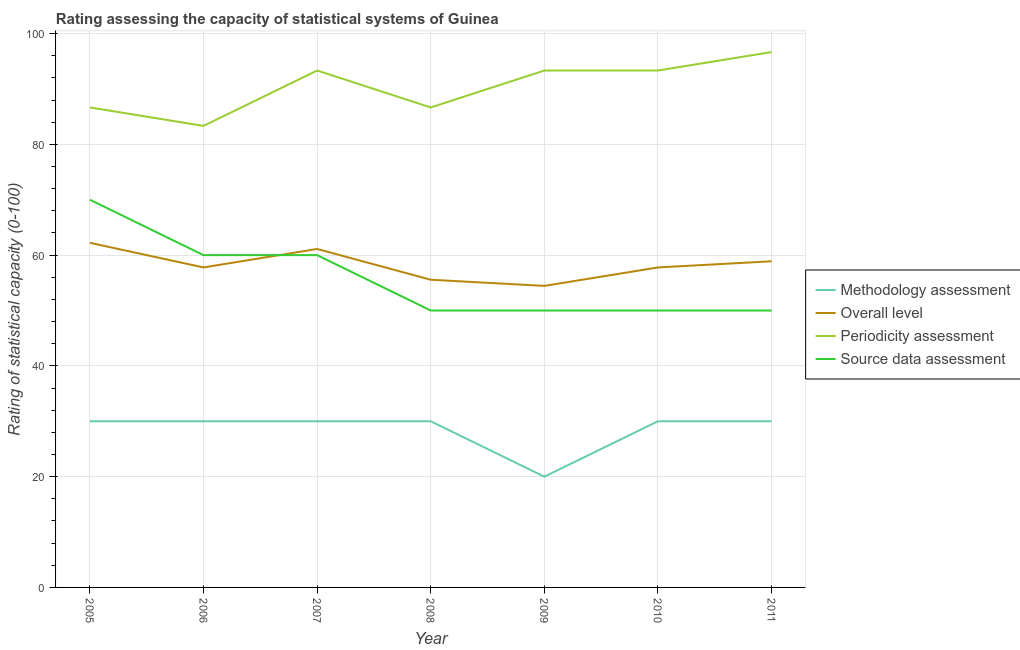How many different coloured lines are there?
Your answer should be compact. 4. What is the source data assessment rating in 2011?
Provide a short and direct response. 50. Across all years, what is the maximum periodicity assessment rating?
Give a very brief answer. 96.67. Across all years, what is the minimum methodology assessment rating?
Make the answer very short. 20. In which year was the source data assessment rating maximum?
Make the answer very short. 2005. In which year was the methodology assessment rating minimum?
Make the answer very short. 2009. What is the total methodology assessment rating in the graph?
Make the answer very short. 200. What is the difference between the methodology assessment rating in 2006 and that in 2010?
Provide a short and direct response. 0. What is the difference between the periodicity assessment rating in 2011 and the methodology assessment rating in 2005?
Your response must be concise. 66.67. What is the average overall level rating per year?
Your answer should be compact. 58.25. In the year 2011, what is the difference between the periodicity assessment rating and source data assessment rating?
Make the answer very short. 46.67. In how many years, is the methodology assessment rating greater than 12?
Make the answer very short. 7. What is the ratio of the overall level rating in 2005 to that in 2009?
Your response must be concise. 1.14. What is the difference between the highest and the second highest periodicity assessment rating?
Your response must be concise. 3.33. What is the difference between the highest and the lowest periodicity assessment rating?
Your answer should be compact. 13.33. In how many years, is the source data assessment rating greater than the average source data assessment rating taken over all years?
Keep it short and to the point. 3. Is the sum of the methodology assessment rating in 2007 and 2009 greater than the maximum overall level rating across all years?
Offer a terse response. No. Is it the case that in every year, the sum of the methodology assessment rating and overall level rating is greater than the periodicity assessment rating?
Provide a short and direct response. No. Does the graph contain any zero values?
Ensure brevity in your answer.  No. Does the graph contain grids?
Ensure brevity in your answer.  Yes. Where does the legend appear in the graph?
Keep it short and to the point. Center right. How are the legend labels stacked?
Offer a terse response. Vertical. What is the title of the graph?
Your answer should be very brief. Rating assessing the capacity of statistical systems of Guinea. Does "Grants and Revenue" appear as one of the legend labels in the graph?
Provide a short and direct response. No. What is the label or title of the X-axis?
Your answer should be very brief. Year. What is the label or title of the Y-axis?
Ensure brevity in your answer.  Rating of statistical capacity (0-100). What is the Rating of statistical capacity (0-100) in Overall level in 2005?
Your answer should be very brief. 62.22. What is the Rating of statistical capacity (0-100) in Periodicity assessment in 2005?
Offer a terse response. 86.67. What is the Rating of statistical capacity (0-100) of Methodology assessment in 2006?
Your answer should be compact. 30. What is the Rating of statistical capacity (0-100) in Overall level in 2006?
Make the answer very short. 57.78. What is the Rating of statistical capacity (0-100) of Periodicity assessment in 2006?
Your response must be concise. 83.33. What is the Rating of statistical capacity (0-100) in Overall level in 2007?
Provide a succinct answer. 61.11. What is the Rating of statistical capacity (0-100) of Periodicity assessment in 2007?
Provide a succinct answer. 93.33. What is the Rating of statistical capacity (0-100) in Source data assessment in 2007?
Give a very brief answer. 60. What is the Rating of statistical capacity (0-100) of Methodology assessment in 2008?
Your answer should be very brief. 30. What is the Rating of statistical capacity (0-100) in Overall level in 2008?
Ensure brevity in your answer.  55.56. What is the Rating of statistical capacity (0-100) in Periodicity assessment in 2008?
Your response must be concise. 86.67. What is the Rating of statistical capacity (0-100) in Source data assessment in 2008?
Your answer should be compact. 50. What is the Rating of statistical capacity (0-100) of Methodology assessment in 2009?
Make the answer very short. 20. What is the Rating of statistical capacity (0-100) of Overall level in 2009?
Your answer should be compact. 54.44. What is the Rating of statistical capacity (0-100) in Periodicity assessment in 2009?
Provide a short and direct response. 93.33. What is the Rating of statistical capacity (0-100) in Source data assessment in 2009?
Offer a very short reply. 50. What is the Rating of statistical capacity (0-100) of Overall level in 2010?
Your response must be concise. 57.78. What is the Rating of statistical capacity (0-100) of Periodicity assessment in 2010?
Offer a terse response. 93.33. What is the Rating of statistical capacity (0-100) of Source data assessment in 2010?
Your response must be concise. 50. What is the Rating of statistical capacity (0-100) of Overall level in 2011?
Offer a terse response. 58.89. What is the Rating of statistical capacity (0-100) of Periodicity assessment in 2011?
Keep it short and to the point. 96.67. What is the Rating of statistical capacity (0-100) in Source data assessment in 2011?
Make the answer very short. 50. Across all years, what is the maximum Rating of statistical capacity (0-100) of Overall level?
Your answer should be compact. 62.22. Across all years, what is the maximum Rating of statistical capacity (0-100) of Periodicity assessment?
Your answer should be very brief. 96.67. Across all years, what is the minimum Rating of statistical capacity (0-100) in Overall level?
Your answer should be very brief. 54.44. Across all years, what is the minimum Rating of statistical capacity (0-100) of Periodicity assessment?
Give a very brief answer. 83.33. What is the total Rating of statistical capacity (0-100) of Overall level in the graph?
Offer a terse response. 407.78. What is the total Rating of statistical capacity (0-100) of Periodicity assessment in the graph?
Provide a succinct answer. 633.33. What is the total Rating of statistical capacity (0-100) in Source data assessment in the graph?
Offer a terse response. 390. What is the difference between the Rating of statistical capacity (0-100) of Overall level in 2005 and that in 2006?
Your answer should be very brief. 4.44. What is the difference between the Rating of statistical capacity (0-100) in Methodology assessment in 2005 and that in 2007?
Your answer should be very brief. 0. What is the difference between the Rating of statistical capacity (0-100) in Overall level in 2005 and that in 2007?
Give a very brief answer. 1.11. What is the difference between the Rating of statistical capacity (0-100) of Periodicity assessment in 2005 and that in 2007?
Your answer should be very brief. -6.67. What is the difference between the Rating of statistical capacity (0-100) in Methodology assessment in 2005 and that in 2008?
Keep it short and to the point. 0. What is the difference between the Rating of statistical capacity (0-100) of Source data assessment in 2005 and that in 2008?
Make the answer very short. 20. What is the difference between the Rating of statistical capacity (0-100) of Methodology assessment in 2005 and that in 2009?
Offer a terse response. 10. What is the difference between the Rating of statistical capacity (0-100) in Overall level in 2005 and that in 2009?
Give a very brief answer. 7.78. What is the difference between the Rating of statistical capacity (0-100) of Periodicity assessment in 2005 and that in 2009?
Your response must be concise. -6.67. What is the difference between the Rating of statistical capacity (0-100) in Methodology assessment in 2005 and that in 2010?
Offer a very short reply. 0. What is the difference between the Rating of statistical capacity (0-100) in Overall level in 2005 and that in 2010?
Give a very brief answer. 4.44. What is the difference between the Rating of statistical capacity (0-100) in Periodicity assessment in 2005 and that in 2010?
Your answer should be very brief. -6.67. What is the difference between the Rating of statistical capacity (0-100) in Methodology assessment in 2005 and that in 2011?
Offer a very short reply. 0. What is the difference between the Rating of statistical capacity (0-100) in Overall level in 2005 and that in 2011?
Provide a succinct answer. 3.33. What is the difference between the Rating of statistical capacity (0-100) in Periodicity assessment in 2005 and that in 2011?
Offer a very short reply. -10. What is the difference between the Rating of statistical capacity (0-100) of Overall level in 2006 and that in 2007?
Give a very brief answer. -3.33. What is the difference between the Rating of statistical capacity (0-100) of Periodicity assessment in 2006 and that in 2007?
Keep it short and to the point. -10. What is the difference between the Rating of statistical capacity (0-100) in Source data assessment in 2006 and that in 2007?
Ensure brevity in your answer.  0. What is the difference between the Rating of statistical capacity (0-100) of Methodology assessment in 2006 and that in 2008?
Offer a terse response. 0. What is the difference between the Rating of statistical capacity (0-100) in Overall level in 2006 and that in 2008?
Your response must be concise. 2.22. What is the difference between the Rating of statistical capacity (0-100) in Methodology assessment in 2006 and that in 2009?
Make the answer very short. 10. What is the difference between the Rating of statistical capacity (0-100) in Periodicity assessment in 2006 and that in 2009?
Provide a succinct answer. -10. What is the difference between the Rating of statistical capacity (0-100) of Source data assessment in 2006 and that in 2009?
Offer a very short reply. 10. What is the difference between the Rating of statistical capacity (0-100) of Methodology assessment in 2006 and that in 2010?
Your response must be concise. 0. What is the difference between the Rating of statistical capacity (0-100) in Overall level in 2006 and that in 2010?
Offer a terse response. 0. What is the difference between the Rating of statistical capacity (0-100) in Source data assessment in 2006 and that in 2010?
Ensure brevity in your answer.  10. What is the difference between the Rating of statistical capacity (0-100) of Overall level in 2006 and that in 2011?
Offer a very short reply. -1.11. What is the difference between the Rating of statistical capacity (0-100) in Periodicity assessment in 2006 and that in 2011?
Your response must be concise. -13.33. What is the difference between the Rating of statistical capacity (0-100) in Overall level in 2007 and that in 2008?
Give a very brief answer. 5.56. What is the difference between the Rating of statistical capacity (0-100) of Source data assessment in 2007 and that in 2008?
Provide a succinct answer. 10. What is the difference between the Rating of statistical capacity (0-100) in Periodicity assessment in 2007 and that in 2009?
Ensure brevity in your answer.  0. What is the difference between the Rating of statistical capacity (0-100) in Overall level in 2007 and that in 2010?
Your answer should be very brief. 3.33. What is the difference between the Rating of statistical capacity (0-100) in Periodicity assessment in 2007 and that in 2010?
Offer a very short reply. 0. What is the difference between the Rating of statistical capacity (0-100) of Overall level in 2007 and that in 2011?
Your answer should be compact. 2.22. What is the difference between the Rating of statistical capacity (0-100) of Periodicity assessment in 2007 and that in 2011?
Keep it short and to the point. -3.33. What is the difference between the Rating of statistical capacity (0-100) in Methodology assessment in 2008 and that in 2009?
Offer a very short reply. 10. What is the difference between the Rating of statistical capacity (0-100) of Periodicity assessment in 2008 and that in 2009?
Make the answer very short. -6.67. What is the difference between the Rating of statistical capacity (0-100) of Source data assessment in 2008 and that in 2009?
Keep it short and to the point. 0. What is the difference between the Rating of statistical capacity (0-100) of Methodology assessment in 2008 and that in 2010?
Provide a succinct answer. 0. What is the difference between the Rating of statistical capacity (0-100) in Overall level in 2008 and that in 2010?
Keep it short and to the point. -2.22. What is the difference between the Rating of statistical capacity (0-100) in Periodicity assessment in 2008 and that in 2010?
Provide a succinct answer. -6.67. What is the difference between the Rating of statistical capacity (0-100) in Source data assessment in 2008 and that in 2010?
Make the answer very short. 0. What is the difference between the Rating of statistical capacity (0-100) in Methodology assessment in 2008 and that in 2011?
Make the answer very short. 0. What is the difference between the Rating of statistical capacity (0-100) of Overall level in 2008 and that in 2011?
Your answer should be compact. -3.33. What is the difference between the Rating of statistical capacity (0-100) in Periodicity assessment in 2008 and that in 2011?
Your response must be concise. -10. What is the difference between the Rating of statistical capacity (0-100) in Source data assessment in 2008 and that in 2011?
Your response must be concise. 0. What is the difference between the Rating of statistical capacity (0-100) of Methodology assessment in 2009 and that in 2011?
Make the answer very short. -10. What is the difference between the Rating of statistical capacity (0-100) of Overall level in 2009 and that in 2011?
Make the answer very short. -4.44. What is the difference between the Rating of statistical capacity (0-100) in Source data assessment in 2009 and that in 2011?
Offer a terse response. 0. What is the difference between the Rating of statistical capacity (0-100) of Methodology assessment in 2010 and that in 2011?
Your answer should be very brief. 0. What is the difference between the Rating of statistical capacity (0-100) in Overall level in 2010 and that in 2011?
Offer a terse response. -1.11. What is the difference between the Rating of statistical capacity (0-100) of Periodicity assessment in 2010 and that in 2011?
Provide a succinct answer. -3.33. What is the difference between the Rating of statistical capacity (0-100) of Source data assessment in 2010 and that in 2011?
Provide a succinct answer. 0. What is the difference between the Rating of statistical capacity (0-100) of Methodology assessment in 2005 and the Rating of statistical capacity (0-100) of Overall level in 2006?
Keep it short and to the point. -27.78. What is the difference between the Rating of statistical capacity (0-100) of Methodology assessment in 2005 and the Rating of statistical capacity (0-100) of Periodicity assessment in 2006?
Your response must be concise. -53.33. What is the difference between the Rating of statistical capacity (0-100) of Overall level in 2005 and the Rating of statistical capacity (0-100) of Periodicity assessment in 2006?
Ensure brevity in your answer.  -21.11. What is the difference between the Rating of statistical capacity (0-100) in Overall level in 2005 and the Rating of statistical capacity (0-100) in Source data assessment in 2006?
Your response must be concise. 2.22. What is the difference between the Rating of statistical capacity (0-100) of Periodicity assessment in 2005 and the Rating of statistical capacity (0-100) of Source data assessment in 2006?
Make the answer very short. 26.67. What is the difference between the Rating of statistical capacity (0-100) in Methodology assessment in 2005 and the Rating of statistical capacity (0-100) in Overall level in 2007?
Your answer should be compact. -31.11. What is the difference between the Rating of statistical capacity (0-100) of Methodology assessment in 2005 and the Rating of statistical capacity (0-100) of Periodicity assessment in 2007?
Give a very brief answer. -63.33. What is the difference between the Rating of statistical capacity (0-100) of Methodology assessment in 2005 and the Rating of statistical capacity (0-100) of Source data assessment in 2007?
Your answer should be compact. -30. What is the difference between the Rating of statistical capacity (0-100) in Overall level in 2005 and the Rating of statistical capacity (0-100) in Periodicity assessment in 2007?
Your answer should be very brief. -31.11. What is the difference between the Rating of statistical capacity (0-100) in Overall level in 2005 and the Rating of statistical capacity (0-100) in Source data assessment in 2007?
Your response must be concise. 2.22. What is the difference between the Rating of statistical capacity (0-100) in Periodicity assessment in 2005 and the Rating of statistical capacity (0-100) in Source data assessment in 2007?
Offer a very short reply. 26.67. What is the difference between the Rating of statistical capacity (0-100) in Methodology assessment in 2005 and the Rating of statistical capacity (0-100) in Overall level in 2008?
Ensure brevity in your answer.  -25.56. What is the difference between the Rating of statistical capacity (0-100) in Methodology assessment in 2005 and the Rating of statistical capacity (0-100) in Periodicity assessment in 2008?
Provide a short and direct response. -56.67. What is the difference between the Rating of statistical capacity (0-100) of Overall level in 2005 and the Rating of statistical capacity (0-100) of Periodicity assessment in 2008?
Give a very brief answer. -24.44. What is the difference between the Rating of statistical capacity (0-100) of Overall level in 2005 and the Rating of statistical capacity (0-100) of Source data assessment in 2008?
Provide a succinct answer. 12.22. What is the difference between the Rating of statistical capacity (0-100) in Periodicity assessment in 2005 and the Rating of statistical capacity (0-100) in Source data assessment in 2008?
Offer a very short reply. 36.67. What is the difference between the Rating of statistical capacity (0-100) of Methodology assessment in 2005 and the Rating of statistical capacity (0-100) of Overall level in 2009?
Ensure brevity in your answer.  -24.44. What is the difference between the Rating of statistical capacity (0-100) in Methodology assessment in 2005 and the Rating of statistical capacity (0-100) in Periodicity assessment in 2009?
Provide a succinct answer. -63.33. What is the difference between the Rating of statistical capacity (0-100) of Methodology assessment in 2005 and the Rating of statistical capacity (0-100) of Source data assessment in 2009?
Ensure brevity in your answer.  -20. What is the difference between the Rating of statistical capacity (0-100) in Overall level in 2005 and the Rating of statistical capacity (0-100) in Periodicity assessment in 2009?
Keep it short and to the point. -31.11. What is the difference between the Rating of statistical capacity (0-100) in Overall level in 2005 and the Rating of statistical capacity (0-100) in Source data assessment in 2009?
Provide a short and direct response. 12.22. What is the difference between the Rating of statistical capacity (0-100) in Periodicity assessment in 2005 and the Rating of statistical capacity (0-100) in Source data assessment in 2009?
Provide a succinct answer. 36.67. What is the difference between the Rating of statistical capacity (0-100) in Methodology assessment in 2005 and the Rating of statistical capacity (0-100) in Overall level in 2010?
Give a very brief answer. -27.78. What is the difference between the Rating of statistical capacity (0-100) in Methodology assessment in 2005 and the Rating of statistical capacity (0-100) in Periodicity assessment in 2010?
Your answer should be very brief. -63.33. What is the difference between the Rating of statistical capacity (0-100) of Overall level in 2005 and the Rating of statistical capacity (0-100) of Periodicity assessment in 2010?
Provide a short and direct response. -31.11. What is the difference between the Rating of statistical capacity (0-100) in Overall level in 2005 and the Rating of statistical capacity (0-100) in Source data assessment in 2010?
Your answer should be compact. 12.22. What is the difference between the Rating of statistical capacity (0-100) of Periodicity assessment in 2005 and the Rating of statistical capacity (0-100) of Source data assessment in 2010?
Offer a very short reply. 36.67. What is the difference between the Rating of statistical capacity (0-100) in Methodology assessment in 2005 and the Rating of statistical capacity (0-100) in Overall level in 2011?
Keep it short and to the point. -28.89. What is the difference between the Rating of statistical capacity (0-100) of Methodology assessment in 2005 and the Rating of statistical capacity (0-100) of Periodicity assessment in 2011?
Offer a terse response. -66.67. What is the difference between the Rating of statistical capacity (0-100) of Methodology assessment in 2005 and the Rating of statistical capacity (0-100) of Source data assessment in 2011?
Provide a short and direct response. -20. What is the difference between the Rating of statistical capacity (0-100) in Overall level in 2005 and the Rating of statistical capacity (0-100) in Periodicity assessment in 2011?
Offer a very short reply. -34.44. What is the difference between the Rating of statistical capacity (0-100) of Overall level in 2005 and the Rating of statistical capacity (0-100) of Source data assessment in 2011?
Keep it short and to the point. 12.22. What is the difference between the Rating of statistical capacity (0-100) of Periodicity assessment in 2005 and the Rating of statistical capacity (0-100) of Source data assessment in 2011?
Ensure brevity in your answer.  36.67. What is the difference between the Rating of statistical capacity (0-100) of Methodology assessment in 2006 and the Rating of statistical capacity (0-100) of Overall level in 2007?
Provide a short and direct response. -31.11. What is the difference between the Rating of statistical capacity (0-100) in Methodology assessment in 2006 and the Rating of statistical capacity (0-100) in Periodicity assessment in 2007?
Ensure brevity in your answer.  -63.33. What is the difference between the Rating of statistical capacity (0-100) of Overall level in 2006 and the Rating of statistical capacity (0-100) of Periodicity assessment in 2007?
Your response must be concise. -35.56. What is the difference between the Rating of statistical capacity (0-100) in Overall level in 2006 and the Rating of statistical capacity (0-100) in Source data assessment in 2007?
Make the answer very short. -2.22. What is the difference between the Rating of statistical capacity (0-100) of Periodicity assessment in 2006 and the Rating of statistical capacity (0-100) of Source data assessment in 2007?
Your answer should be very brief. 23.33. What is the difference between the Rating of statistical capacity (0-100) in Methodology assessment in 2006 and the Rating of statistical capacity (0-100) in Overall level in 2008?
Your answer should be very brief. -25.56. What is the difference between the Rating of statistical capacity (0-100) in Methodology assessment in 2006 and the Rating of statistical capacity (0-100) in Periodicity assessment in 2008?
Provide a short and direct response. -56.67. What is the difference between the Rating of statistical capacity (0-100) in Methodology assessment in 2006 and the Rating of statistical capacity (0-100) in Source data assessment in 2008?
Offer a terse response. -20. What is the difference between the Rating of statistical capacity (0-100) in Overall level in 2006 and the Rating of statistical capacity (0-100) in Periodicity assessment in 2008?
Your answer should be very brief. -28.89. What is the difference between the Rating of statistical capacity (0-100) in Overall level in 2006 and the Rating of statistical capacity (0-100) in Source data assessment in 2008?
Ensure brevity in your answer.  7.78. What is the difference between the Rating of statistical capacity (0-100) in Periodicity assessment in 2006 and the Rating of statistical capacity (0-100) in Source data assessment in 2008?
Offer a terse response. 33.33. What is the difference between the Rating of statistical capacity (0-100) in Methodology assessment in 2006 and the Rating of statistical capacity (0-100) in Overall level in 2009?
Keep it short and to the point. -24.44. What is the difference between the Rating of statistical capacity (0-100) in Methodology assessment in 2006 and the Rating of statistical capacity (0-100) in Periodicity assessment in 2009?
Provide a short and direct response. -63.33. What is the difference between the Rating of statistical capacity (0-100) in Overall level in 2006 and the Rating of statistical capacity (0-100) in Periodicity assessment in 2009?
Offer a very short reply. -35.56. What is the difference between the Rating of statistical capacity (0-100) of Overall level in 2006 and the Rating of statistical capacity (0-100) of Source data assessment in 2009?
Keep it short and to the point. 7.78. What is the difference between the Rating of statistical capacity (0-100) of Periodicity assessment in 2006 and the Rating of statistical capacity (0-100) of Source data assessment in 2009?
Your answer should be very brief. 33.33. What is the difference between the Rating of statistical capacity (0-100) of Methodology assessment in 2006 and the Rating of statistical capacity (0-100) of Overall level in 2010?
Ensure brevity in your answer.  -27.78. What is the difference between the Rating of statistical capacity (0-100) of Methodology assessment in 2006 and the Rating of statistical capacity (0-100) of Periodicity assessment in 2010?
Ensure brevity in your answer.  -63.33. What is the difference between the Rating of statistical capacity (0-100) in Overall level in 2006 and the Rating of statistical capacity (0-100) in Periodicity assessment in 2010?
Keep it short and to the point. -35.56. What is the difference between the Rating of statistical capacity (0-100) of Overall level in 2006 and the Rating of statistical capacity (0-100) of Source data assessment in 2010?
Keep it short and to the point. 7.78. What is the difference between the Rating of statistical capacity (0-100) in Periodicity assessment in 2006 and the Rating of statistical capacity (0-100) in Source data assessment in 2010?
Offer a terse response. 33.33. What is the difference between the Rating of statistical capacity (0-100) of Methodology assessment in 2006 and the Rating of statistical capacity (0-100) of Overall level in 2011?
Ensure brevity in your answer.  -28.89. What is the difference between the Rating of statistical capacity (0-100) in Methodology assessment in 2006 and the Rating of statistical capacity (0-100) in Periodicity assessment in 2011?
Your answer should be very brief. -66.67. What is the difference between the Rating of statistical capacity (0-100) in Overall level in 2006 and the Rating of statistical capacity (0-100) in Periodicity assessment in 2011?
Your response must be concise. -38.89. What is the difference between the Rating of statistical capacity (0-100) in Overall level in 2006 and the Rating of statistical capacity (0-100) in Source data assessment in 2011?
Provide a short and direct response. 7.78. What is the difference between the Rating of statistical capacity (0-100) in Periodicity assessment in 2006 and the Rating of statistical capacity (0-100) in Source data assessment in 2011?
Ensure brevity in your answer.  33.33. What is the difference between the Rating of statistical capacity (0-100) of Methodology assessment in 2007 and the Rating of statistical capacity (0-100) of Overall level in 2008?
Your answer should be very brief. -25.56. What is the difference between the Rating of statistical capacity (0-100) of Methodology assessment in 2007 and the Rating of statistical capacity (0-100) of Periodicity assessment in 2008?
Your response must be concise. -56.67. What is the difference between the Rating of statistical capacity (0-100) of Overall level in 2007 and the Rating of statistical capacity (0-100) of Periodicity assessment in 2008?
Your answer should be very brief. -25.56. What is the difference between the Rating of statistical capacity (0-100) of Overall level in 2007 and the Rating of statistical capacity (0-100) of Source data assessment in 2008?
Your answer should be very brief. 11.11. What is the difference between the Rating of statistical capacity (0-100) of Periodicity assessment in 2007 and the Rating of statistical capacity (0-100) of Source data assessment in 2008?
Offer a very short reply. 43.33. What is the difference between the Rating of statistical capacity (0-100) in Methodology assessment in 2007 and the Rating of statistical capacity (0-100) in Overall level in 2009?
Your answer should be very brief. -24.44. What is the difference between the Rating of statistical capacity (0-100) in Methodology assessment in 2007 and the Rating of statistical capacity (0-100) in Periodicity assessment in 2009?
Ensure brevity in your answer.  -63.33. What is the difference between the Rating of statistical capacity (0-100) in Overall level in 2007 and the Rating of statistical capacity (0-100) in Periodicity assessment in 2009?
Provide a short and direct response. -32.22. What is the difference between the Rating of statistical capacity (0-100) of Overall level in 2007 and the Rating of statistical capacity (0-100) of Source data assessment in 2009?
Give a very brief answer. 11.11. What is the difference between the Rating of statistical capacity (0-100) in Periodicity assessment in 2007 and the Rating of statistical capacity (0-100) in Source data assessment in 2009?
Ensure brevity in your answer.  43.33. What is the difference between the Rating of statistical capacity (0-100) in Methodology assessment in 2007 and the Rating of statistical capacity (0-100) in Overall level in 2010?
Offer a very short reply. -27.78. What is the difference between the Rating of statistical capacity (0-100) of Methodology assessment in 2007 and the Rating of statistical capacity (0-100) of Periodicity assessment in 2010?
Offer a very short reply. -63.33. What is the difference between the Rating of statistical capacity (0-100) in Overall level in 2007 and the Rating of statistical capacity (0-100) in Periodicity assessment in 2010?
Make the answer very short. -32.22. What is the difference between the Rating of statistical capacity (0-100) of Overall level in 2007 and the Rating of statistical capacity (0-100) of Source data assessment in 2010?
Offer a very short reply. 11.11. What is the difference between the Rating of statistical capacity (0-100) of Periodicity assessment in 2007 and the Rating of statistical capacity (0-100) of Source data assessment in 2010?
Keep it short and to the point. 43.33. What is the difference between the Rating of statistical capacity (0-100) in Methodology assessment in 2007 and the Rating of statistical capacity (0-100) in Overall level in 2011?
Your answer should be very brief. -28.89. What is the difference between the Rating of statistical capacity (0-100) in Methodology assessment in 2007 and the Rating of statistical capacity (0-100) in Periodicity assessment in 2011?
Your response must be concise. -66.67. What is the difference between the Rating of statistical capacity (0-100) of Overall level in 2007 and the Rating of statistical capacity (0-100) of Periodicity assessment in 2011?
Your answer should be very brief. -35.56. What is the difference between the Rating of statistical capacity (0-100) in Overall level in 2007 and the Rating of statistical capacity (0-100) in Source data assessment in 2011?
Offer a terse response. 11.11. What is the difference between the Rating of statistical capacity (0-100) in Periodicity assessment in 2007 and the Rating of statistical capacity (0-100) in Source data assessment in 2011?
Offer a terse response. 43.33. What is the difference between the Rating of statistical capacity (0-100) in Methodology assessment in 2008 and the Rating of statistical capacity (0-100) in Overall level in 2009?
Your answer should be very brief. -24.44. What is the difference between the Rating of statistical capacity (0-100) of Methodology assessment in 2008 and the Rating of statistical capacity (0-100) of Periodicity assessment in 2009?
Ensure brevity in your answer.  -63.33. What is the difference between the Rating of statistical capacity (0-100) of Methodology assessment in 2008 and the Rating of statistical capacity (0-100) of Source data assessment in 2009?
Offer a terse response. -20. What is the difference between the Rating of statistical capacity (0-100) in Overall level in 2008 and the Rating of statistical capacity (0-100) in Periodicity assessment in 2009?
Your answer should be compact. -37.78. What is the difference between the Rating of statistical capacity (0-100) of Overall level in 2008 and the Rating of statistical capacity (0-100) of Source data assessment in 2009?
Your answer should be compact. 5.56. What is the difference between the Rating of statistical capacity (0-100) in Periodicity assessment in 2008 and the Rating of statistical capacity (0-100) in Source data assessment in 2009?
Keep it short and to the point. 36.67. What is the difference between the Rating of statistical capacity (0-100) of Methodology assessment in 2008 and the Rating of statistical capacity (0-100) of Overall level in 2010?
Ensure brevity in your answer.  -27.78. What is the difference between the Rating of statistical capacity (0-100) in Methodology assessment in 2008 and the Rating of statistical capacity (0-100) in Periodicity assessment in 2010?
Provide a short and direct response. -63.33. What is the difference between the Rating of statistical capacity (0-100) in Methodology assessment in 2008 and the Rating of statistical capacity (0-100) in Source data assessment in 2010?
Make the answer very short. -20. What is the difference between the Rating of statistical capacity (0-100) of Overall level in 2008 and the Rating of statistical capacity (0-100) of Periodicity assessment in 2010?
Provide a succinct answer. -37.78. What is the difference between the Rating of statistical capacity (0-100) in Overall level in 2008 and the Rating of statistical capacity (0-100) in Source data assessment in 2010?
Offer a terse response. 5.56. What is the difference between the Rating of statistical capacity (0-100) in Periodicity assessment in 2008 and the Rating of statistical capacity (0-100) in Source data assessment in 2010?
Provide a succinct answer. 36.67. What is the difference between the Rating of statistical capacity (0-100) of Methodology assessment in 2008 and the Rating of statistical capacity (0-100) of Overall level in 2011?
Keep it short and to the point. -28.89. What is the difference between the Rating of statistical capacity (0-100) in Methodology assessment in 2008 and the Rating of statistical capacity (0-100) in Periodicity assessment in 2011?
Your response must be concise. -66.67. What is the difference between the Rating of statistical capacity (0-100) of Methodology assessment in 2008 and the Rating of statistical capacity (0-100) of Source data assessment in 2011?
Give a very brief answer. -20. What is the difference between the Rating of statistical capacity (0-100) in Overall level in 2008 and the Rating of statistical capacity (0-100) in Periodicity assessment in 2011?
Your response must be concise. -41.11. What is the difference between the Rating of statistical capacity (0-100) in Overall level in 2008 and the Rating of statistical capacity (0-100) in Source data assessment in 2011?
Offer a terse response. 5.56. What is the difference between the Rating of statistical capacity (0-100) of Periodicity assessment in 2008 and the Rating of statistical capacity (0-100) of Source data assessment in 2011?
Ensure brevity in your answer.  36.67. What is the difference between the Rating of statistical capacity (0-100) of Methodology assessment in 2009 and the Rating of statistical capacity (0-100) of Overall level in 2010?
Your answer should be very brief. -37.78. What is the difference between the Rating of statistical capacity (0-100) in Methodology assessment in 2009 and the Rating of statistical capacity (0-100) in Periodicity assessment in 2010?
Keep it short and to the point. -73.33. What is the difference between the Rating of statistical capacity (0-100) of Overall level in 2009 and the Rating of statistical capacity (0-100) of Periodicity assessment in 2010?
Your answer should be very brief. -38.89. What is the difference between the Rating of statistical capacity (0-100) in Overall level in 2009 and the Rating of statistical capacity (0-100) in Source data assessment in 2010?
Your response must be concise. 4.44. What is the difference between the Rating of statistical capacity (0-100) of Periodicity assessment in 2009 and the Rating of statistical capacity (0-100) of Source data assessment in 2010?
Your answer should be compact. 43.33. What is the difference between the Rating of statistical capacity (0-100) in Methodology assessment in 2009 and the Rating of statistical capacity (0-100) in Overall level in 2011?
Offer a very short reply. -38.89. What is the difference between the Rating of statistical capacity (0-100) in Methodology assessment in 2009 and the Rating of statistical capacity (0-100) in Periodicity assessment in 2011?
Provide a succinct answer. -76.67. What is the difference between the Rating of statistical capacity (0-100) of Methodology assessment in 2009 and the Rating of statistical capacity (0-100) of Source data assessment in 2011?
Provide a succinct answer. -30. What is the difference between the Rating of statistical capacity (0-100) in Overall level in 2009 and the Rating of statistical capacity (0-100) in Periodicity assessment in 2011?
Make the answer very short. -42.22. What is the difference between the Rating of statistical capacity (0-100) in Overall level in 2009 and the Rating of statistical capacity (0-100) in Source data assessment in 2011?
Offer a very short reply. 4.44. What is the difference between the Rating of statistical capacity (0-100) of Periodicity assessment in 2009 and the Rating of statistical capacity (0-100) of Source data assessment in 2011?
Your answer should be compact. 43.33. What is the difference between the Rating of statistical capacity (0-100) of Methodology assessment in 2010 and the Rating of statistical capacity (0-100) of Overall level in 2011?
Provide a short and direct response. -28.89. What is the difference between the Rating of statistical capacity (0-100) in Methodology assessment in 2010 and the Rating of statistical capacity (0-100) in Periodicity assessment in 2011?
Provide a succinct answer. -66.67. What is the difference between the Rating of statistical capacity (0-100) in Methodology assessment in 2010 and the Rating of statistical capacity (0-100) in Source data assessment in 2011?
Offer a terse response. -20. What is the difference between the Rating of statistical capacity (0-100) of Overall level in 2010 and the Rating of statistical capacity (0-100) of Periodicity assessment in 2011?
Make the answer very short. -38.89. What is the difference between the Rating of statistical capacity (0-100) of Overall level in 2010 and the Rating of statistical capacity (0-100) of Source data assessment in 2011?
Keep it short and to the point. 7.78. What is the difference between the Rating of statistical capacity (0-100) of Periodicity assessment in 2010 and the Rating of statistical capacity (0-100) of Source data assessment in 2011?
Provide a succinct answer. 43.33. What is the average Rating of statistical capacity (0-100) of Methodology assessment per year?
Provide a short and direct response. 28.57. What is the average Rating of statistical capacity (0-100) of Overall level per year?
Provide a succinct answer. 58.25. What is the average Rating of statistical capacity (0-100) of Periodicity assessment per year?
Your answer should be very brief. 90.48. What is the average Rating of statistical capacity (0-100) in Source data assessment per year?
Keep it short and to the point. 55.71. In the year 2005, what is the difference between the Rating of statistical capacity (0-100) in Methodology assessment and Rating of statistical capacity (0-100) in Overall level?
Your response must be concise. -32.22. In the year 2005, what is the difference between the Rating of statistical capacity (0-100) in Methodology assessment and Rating of statistical capacity (0-100) in Periodicity assessment?
Your response must be concise. -56.67. In the year 2005, what is the difference between the Rating of statistical capacity (0-100) in Overall level and Rating of statistical capacity (0-100) in Periodicity assessment?
Your answer should be compact. -24.44. In the year 2005, what is the difference between the Rating of statistical capacity (0-100) in Overall level and Rating of statistical capacity (0-100) in Source data assessment?
Give a very brief answer. -7.78. In the year 2005, what is the difference between the Rating of statistical capacity (0-100) of Periodicity assessment and Rating of statistical capacity (0-100) of Source data assessment?
Offer a terse response. 16.67. In the year 2006, what is the difference between the Rating of statistical capacity (0-100) in Methodology assessment and Rating of statistical capacity (0-100) in Overall level?
Your answer should be very brief. -27.78. In the year 2006, what is the difference between the Rating of statistical capacity (0-100) of Methodology assessment and Rating of statistical capacity (0-100) of Periodicity assessment?
Offer a terse response. -53.33. In the year 2006, what is the difference between the Rating of statistical capacity (0-100) in Methodology assessment and Rating of statistical capacity (0-100) in Source data assessment?
Ensure brevity in your answer.  -30. In the year 2006, what is the difference between the Rating of statistical capacity (0-100) of Overall level and Rating of statistical capacity (0-100) of Periodicity assessment?
Your response must be concise. -25.56. In the year 2006, what is the difference between the Rating of statistical capacity (0-100) of Overall level and Rating of statistical capacity (0-100) of Source data assessment?
Your answer should be very brief. -2.22. In the year 2006, what is the difference between the Rating of statistical capacity (0-100) in Periodicity assessment and Rating of statistical capacity (0-100) in Source data assessment?
Provide a succinct answer. 23.33. In the year 2007, what is the difference between the Rating of statistical capacity (0-100) in Methodology assessment and Rating of statistical capacity (0-100) in Overall level?
Provide a succinct answer. -31.11. In the year 2007, what is the difference between the Rating of statistical capacity (0-100) in Methodology assessment and Rating of statistical capacity (0-100) in Periodicity assessment?
Your response must be concise. -63.33. In the year 2007, what is the difference between the Rating of statistical capacity (0-100) in Overall level and Rating of statistical capacity (0-100) in Periodicity assessment?
Make the answer very short. -32.22. In the year 2007, what is the difference between the Rating of statistical capacity (0-100) in Periodicity assessment and Rating of statistical capacity (0-100) in Source data assessment?
Make the answer very short. 33.33. In the year 2008, what is the difference between the Rating of statistical capacity (0-100) of Methodology assessment and Rating of statistical capacity (0-100) of Overall level?
Your response must be concise. -25.56. In the year 2008, what is the difference between the Rating of statistical capacity (0-100) of Methodology assessment and Rating of statistical capacity (0-100) of Periodicity assessment?
Your response must be concise. -56.67. In the year 2008, what is the difference between the Rating of statistical capacity (0-100) of Methodology assessment and Rating of statistical capacity (0-100) of Source data assessment?
Provide a succinct answer. -20. In the year 2008, what is the difference between the Rating of statistical capacity (0-100) of Overall level and Rating of statistical capacity (0-100) of Periodicity assessment?
Provide a succinct answer. -31.11. In the year 2008, what is the difference between the Rating of statistical capacity (0-100) in Overall level and Rating of statistical capacity (0-100) in Source data assessment?
Ensure brevity in your answer.  5.56. In the year 2008, what is the difference between the Rating of statistical capacity (0-100) in Periodicity assessment and Rating of statistical capacity (0-100) in Source data assessment?
Provide a succinct answer. 36.67. In the year 2009, what is the difference between the Rating of statistical capacity (0-100) of Methodology assessment and Rating of statistical capacity (0-100) of Overall level?
Offer a very short reply. -34.44. In the year 2009, what is the difference between the Rating of statistical capacity (0-100) in Methodology assessment and Rating of statistical capacity (0-100) in Periodicity assessment?
Offer a terse response. -73.33. In the year 2009, what is the difference between the Rating of statistical capacity (0-100) in Overall level and Rating of statistical capacity (0-100) in Periodicity assessment?
Give a very brief answer. -38.89. In the year 2009, what is the difference between the Rating of statistical capacity (0-100) in Overall level and Rating of statistical capacity (0-100) in Source data assessment?
Offer a very short reply. 4.44. In the year 2009, what is the difference between the Rating of statistical capacity (0-100) in Periodicity assessment and Rating of statistical capacity (0-100) in Source data assessment?
Make the answer very short. 43.33. In the year 2010, what is the difference between the Rating of statistical capacity (0-100) in Methodology assessment and Rating of statistical capacity (0-100) in Overall level?
Provide a succinct answer. -27.78. In the year 2010, what is the difference between the Rating of statistical capacity (0-100) of Methodology assessment and Rating of statistical capacity (0-100) of Periodicity assessment?
Give a very brief answer. -63.33. In the year 2010, what is the difference between the Rating of statistical capacity (0-100) in Methodology assessment and Rating of statistical capacity (0-100) in Source data assessment?
Provide a short and direct response. -20. In the year 2010, what is the difference between the Rating of statistical capacity (0-100) in Overall level and Rating of statistical capacity (0-100) in Periodicity assessment?
Provide a succinct answer. -35.56. In the year 2010, what is the difference between the Rating of statistical capacity (0-100) of Overall level and Rating of statistical capacity (0-100) of Source data assessment?
Make the answer very short. 7.78. In the year 2010, what is the difference between the Rating of statistical capacity (0-100) in Periodicity assessment and Rating of statistical capacity (0-100) in Source data assessment?
Give a very brief answer. 43.33. In the year 2011, what is the difference between the Rating of statistical capacity (0-100) of Methodology assessment and Rating of statistical capacity (0-100) of Overall level?
Your response must be concise. -28.89. In the year 2011, what is the difference between the Rating of statistical capacity (0-100) of Methodology assessment and Rating of statistical capacity (0-100) of Periodicity assessment?
Keep it short and to the point. -66.67. In the year 2011, what is the difference between the Rating of statistical capacity (0-100) of Overall level and Rating of statistical capacity (0-100) of Periodicity assessment?
Your response must be concise. -37.78. In the year 2011, what is the difference between the Rating of statistical capacity (0-100) in Overall level and Rating of statistical capacity (0-100) in Source data assessment?
Offer a very short reply. 8.89. In the year 2011, what is the difference between the Rating of statistical capacity (0-100) in Periodicity assessment and Rating of statistical capacity (0-100) in Source data assessment?
Your response must be concise. 46.67. What is the ratio of the Rating of statistical capacity (0-100) of Overall level in 2005 to that in 2006?
Offer a terse response. 1.08. What is the ratio of the Rating of statistical capacity (0-100) in Periodicity assessment in 2005 to that in 2006?
Make the answer very short. 1.04. What is the ratio of the Rating of statistical capacity (0-100) of Overall level in 2005 to that in 2007?
Provide a short and direct response. 1.02. What is the ratio of the Rating of statistical capacity (0-100) of Methodology assessment in 2005 to that in 2008?
Your answer should be very brief. 1. What is the ratio of the Rating of statistical capacity (0-100) of Overall level in 2005 to that in 2008?
Your response must be concise. 1.12. What is the ratio of the Rating of statistical capacity (0-100) in Periodicity assessment in 2005 to that in 2008?
Provide a succinct answer. 1. What is the ratio of the Rating of statistical capacity (0-100) of Methodology assessment in 2005 to that in 2010?
Give a very brief answer. 1. What is the ratio of the Rating of statistical capacity (0-100) in Overall level in 2005 to that in 2010?
Your answer should be very brief. 1.08. What is the ratio of the Rating of statistical capacity (0-100) in Periodicity assessment in 2005 to that in 2010?
Your answer should be compact. 0.93. What is the ratio of the Rating of statistical capacity (0-100) of Source data assessment in 2005 to that in 2010?
Your answer should be compact. 1.4. What is the ratio of the Rating of statistical capacity (0-100) in Overall level in 2005 to that in 2011?
Keep it short and to the point. 1.06. What is the ratio of the Rating of statistical capacity (0-100) in Periodicity assessment in 2005 to that in 2011?
Your answer should be compact. 0.9. What is the ratio of the Rating of statistical capacity (0-100) of Source data assessment in 2005 to that in 2011?
Provide a short and direct response. 1.4. What is the ratio of the Rating of statistical capacity (0-100) in Methodology assessment in 2006 to that in 2007?
Your response must be concise. 1. What is the ratio of the Rating of statistical capacity (0-100) in Overall level in 2006 to that in 2007?
Your response must be concise. 0.95. What is the ratio of the Rating of statistical capacity (0-100) in Periodicity assessment in 2006 to that in 2007?
Your response must be concise. 0.89. What is the ratio of the Rating of statistical capacity (0-100) of Overall level in 2006 to that in 2008?
Keep it short and to the point. 1.04. What is the ratio of the Rating of statistical capacity (0-100) of Periodicity assessment in 2006 to that in 2008?
Keep it short and to the point. 0.96. What is the ratio of the Rating of statistical capacity (0-100) in Source data assessment in 2006 to that in 2008?
Provide a short and direct response. 1.2. What is the ratio of the Rating of statistical capacity (0-100) in Overall level in 2006 to that in 2009?
Ensure brevity in your answer.  1.06. What is the ratio of the Rating of statistical capacity (0-100) in Periodicity assessment in 2006 to that in 2009?
Your answer should be compact. 0.89. What is the ratio of the Rating of statistical capacity (0-100) of Overall level in 2006 to that in 2010?
Make the answer very short. 1. What is the ratio of the Rating of statistical capacity (0-100) in Periodicity assessment in 2006 to that in 2010?
Provide a succinct answer. 0.89. What is the ratio of the Rating of statistical capacity (0-100) of Source data assessment in 2006 to that in 2010?
Give a very brief answer. 1.2. What is the ratio of the Rating of statistical capacity (0-100) in Overall level in 2006 to that in 2011?
Offer a very short reply. 0.98. What is the ratio of the Rating of statistical capacity (0-100) in Periodicity assessment in 2006 to that in 2011?
Ensure brevity in your answer.  0.86. What is the ratio of the Rating of statistical capacity (0-100) in Overall level in 2007 to that in 2009?
Provide a short and direct response. 1.12. What is the ratio of the Rating of statistical capacity (0-100) of Periodicity assessment in 2007 to that in 2009?
Your answer should be very brief. 1. What is the ratio of the Rating of statistical capacity (0-100) of Methodology assessment in 2007 to that in 2010?
Provide a short and direct response. 1. What is the ratio of the Rating of statistical capacity (0-100) in Overall level in 2007 to that in 2010?
Ensure brevity in your answer.  1.06. What is the ratio of the Rating of statistical capacity (0-100) of Periodicity assessment in 2007 to that in 2010?
Ensure brevity in your answer.  1. What is the ratio of the Rating of statistical capacity (0-100) in Methodology assessment in 2007 to that in 2011?
Keep it short and to the point. 1. What is the ratio of the Rating of statistical capacity (0-100) of Overall level in 2007 to that in 2011?
Offer a very short reply. 1.04. What is the ratio of the Rating of statistical capacity (0-100) in Periodicity assessment in 2007 to that in 2011?
Offer a very short reply. 0.97. What is the ratio of the Rating of statistical capacity (0-100) in Methodology assessment in 2008 to that in 2009?
Your response must be concise. 1.5. What is the ratio of the Rating of statistical capacity (0-100) of Overall level in 2008 to that in 2009?
Offer a very short reply. 1.02. What is the ratio of the Rating of statistical capacity (0-100) in Periodicity assessment in 2008 to that in 2009?
Ensure brevity in your answer.  0.93. What is the ratio of the Rating of statistical capacity (0-100) in Source data assessment in 2008 to that in 2009?
Keep it short and to the point. 1. What is the ratio of the Rating of statistical capacity (0-100) of Methodology assessment in 2008 to that in 2010?
Provide a short and direct response. 1. What is the ratio of the Rating of statistical capacity (0-100) in Overall level in 2008 to that in 2010?
Ensure brevity in your answer.  0.96. What is the ratio of the Rating of statistical capacity (0-100) of Periodicity assessment in 2008 to that in 2010?
Your answer should be very brief. 0.93. What is the ratio of the Rating of statistical capacity (0-100) of Methodology assessment in 2008 to that in 2011?
Your answer should be compact. 1. What is the ratio of the Rating of statistical capacity (0-100) of Overall level in 2008 to that in 2011?
Offer a terse response. 0.94. What is the ratio of the Rating of statistical capacity (0-100) in Periodicity assessment in 2008 to that in 2011?
Provide a short and direct response. 0.9. What is the ratio of the Rating of statistical capacity (0-100) in Methodology assessment in 2009 to that in 2010?
Offer a very short reply. 0.67. What is the ratio of the Rating of statistical capacity (0-100) of Overall level in 2009 to that in 2010?
Your answer should be compact. 0.94. What is the ratio of the Rating of statistical capacity (0-100) of Methodology assessment in 2009 to that in 2011?
Offer a very short reply. 0.67. What is the ratio of the Rating of statistical capacity (0-100) of Overall level in 2009 to that in 2011?
Offer a terse response. 0.92. What is the ratio of the Rating of statistical capacity (0-100) in Periodicity assessment in 2009 to that in 2011?
Your response must be concise. 0.97. What is the ratio of the Rating of statistical capacity (0-100) in Source data assessment in 2009 to that in 2011?
Make the answer very short. 1. What is the ratio of the Rating of statistical capacity (0-100) of Overall level in 2010 to that in 2011?
Provide a short and direct response. 0.98. What is the ratio of the Rating of statistical capacity (0-100) of Periodicity assessment in 2010 to that in 2011?
Offer a terse response. 0.97. What is the ratio of the Rating of statistical capacity (0-100) in Source data assessment in 2010 to that in 2011?
Your response must be concise. 1. What is the difference between the highest and the second highest Rating of statistical capacity (0-100) in Methodology assessment?
Keep it short and to the point. 0. What is the difference between the highest and the second highest Rating of statistical capacity (0-100) in Overall level?
Offer a terse response. 1.11. What is the difference between the highest and the second highest Rating of statistical capacity (0-100) in Source data assessment?
Ensure brevity in your answer.  10. What is the difference between the highest and the lowest Rating of statistical capacity (0-100) in Methodology assessment?
Keep it short and to the point. 10. What is the difference between the highest and the lowest Rating of statistical capacity (0-100) of Overall level?
Ensure brevity in your answer.  7.78. What is the difference between the highest and the lowest Rating of statistical capacity (0-100) in Periodicity assessment?
Provide a short and direct response. 13.33. What is the difference between the highest and the lowest Rating of statistical capacity (0-100) of Source data assessment?
Your response must be concise. 20. 